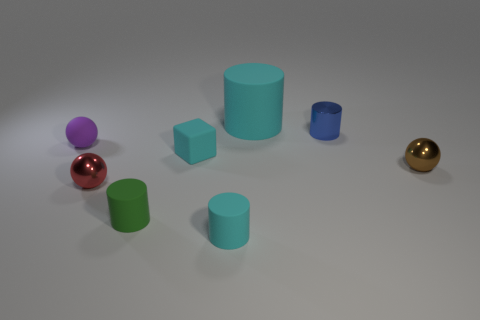Subtract 1 cylinders. How many cylinders are left? 3 Add 1 gray metal objects. How many objects exist? 9 Subtract all balls. How many objects are left? 5 Subtract 1 cyan cubes. How many objects are left? 7 Subtract all tiny metallic cylinders. Subtract all red things. How many objects are left? 6 Add 6 big cyan matte cylinders. How many big cyan matte cylinders are left? 7 Add 5 yellow things. How many yellow things exist? 5 